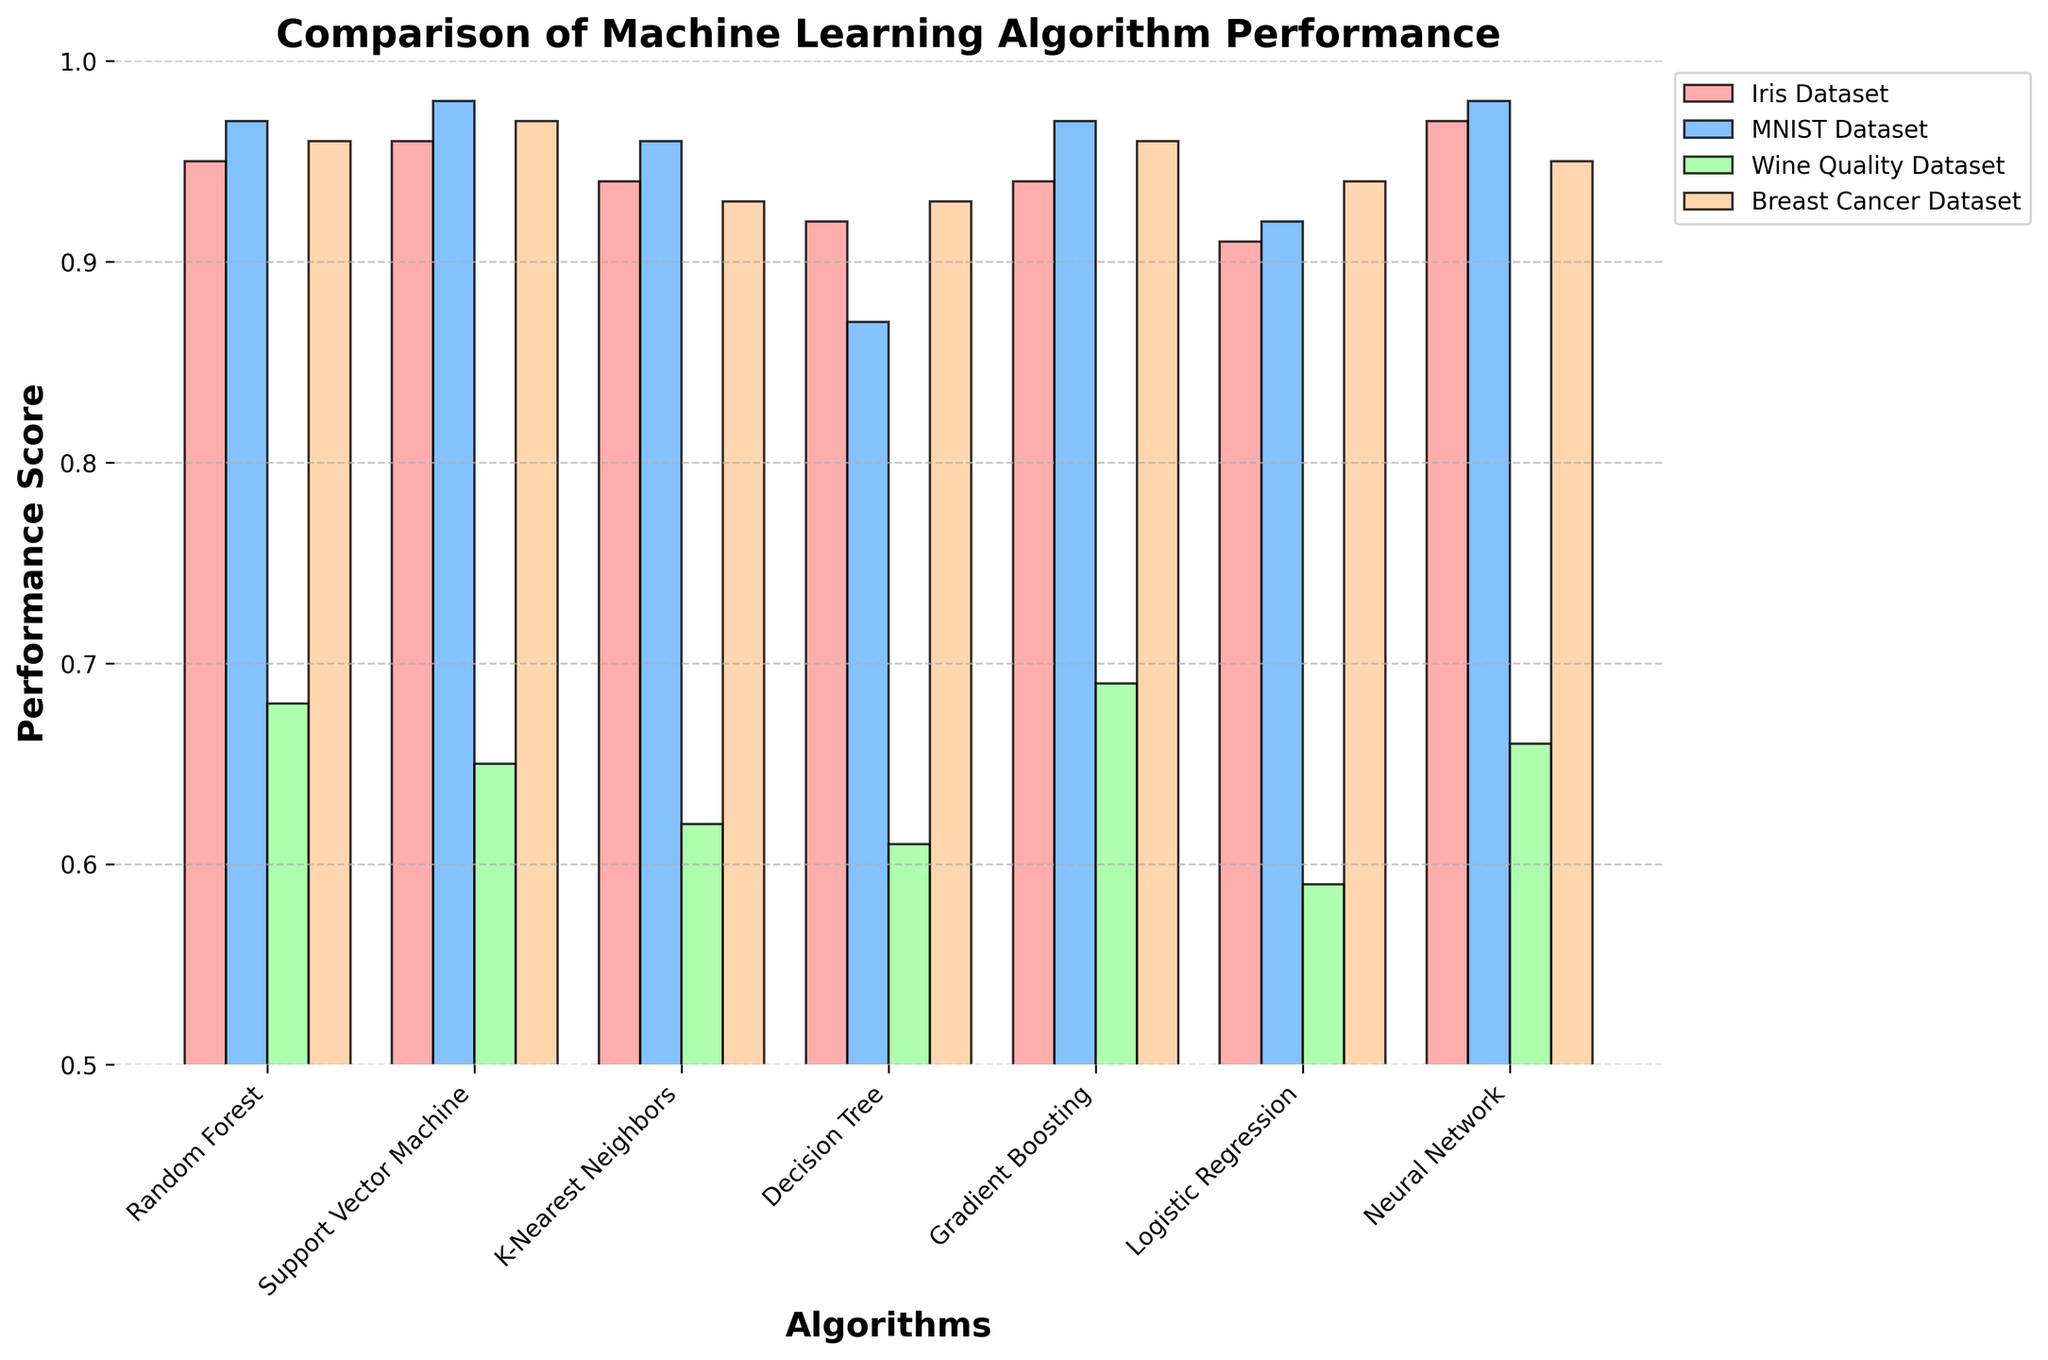What algorithm has the highest performance score on the Iris Dataset? Find the bar that reaches the highest point among the Iris Dataset bars. The Neural Network bar is the tallest for the Iris Dataset.
Answer: Neural Network How does the performance of Random Forest and Gradient Boosting compare on the Wine Quality Dataset? Compare the heights of the bars representing Random Forest and Gradient Boosting for the Wine Quality Dataset. Gradient Boosting is slightly higher.
Answer: Gradient Boosting Which algorithm has the lowest performance score on the MNIST Dataset? Look for the shortest bar in the MNIST Dataset group. The Decision Tree bar is the shortest.
Answer: Decision Tree What is the average performance score of the K-Nearest Neighbors algorithm across all datasets? Sum the performance scores of K-Nearest Neighbors for each dataset and divide by the number of datasets: (0.94+0.96+0.62+0.93)/4 = 3.45/4 = 0.8625.
Answer: 0.86 Which dataset has the most algorithms performing at 0.97 or higher? Identify the number of bars at or above 0.97 for each dataset. MNIST has three (Random Forest, Support Vector Machine, Neural Network).
Answer: MNIST Dataset How much higher is the Support Vector Machine's performance on the MNIST Dataset compared to the Wine Quality Dataset? Subtract the performance score of Support Vector Machine on the Wine Quality Dataset from the MNIST Dataset: 0.98 - 0.65 = 0.33.
Answer: 0.33 What's the range of performance scores for the Logistic Regression algorithm across all datasets? Identify the highest and lowest scores for Logistic Regression and calculate the difference: 0.94 (highest) - 0.59 (lowest) = 0.35.
Answer: 0.35 Which algorithm has a performance of 0.93 on more than one dataset? Look at the bars reaching 0.93. K-Nearest Neighbors and Decision Tree both have 0.93 on the Breast Cancer Dataset.
Answer: K-Nearest Neighbors and Decision Tree What are the unique performance scores achieved by the Neural Network algorithm across all datasets? List the performance scores shown for Neural Network across all four datasets: 0.97 (Iris), 0.98 (MNIST), 0.66 (Wine Quality), 0.95 (Breast Cancer).
Answer: 0.97, 0.98, 0.66, 0.95 